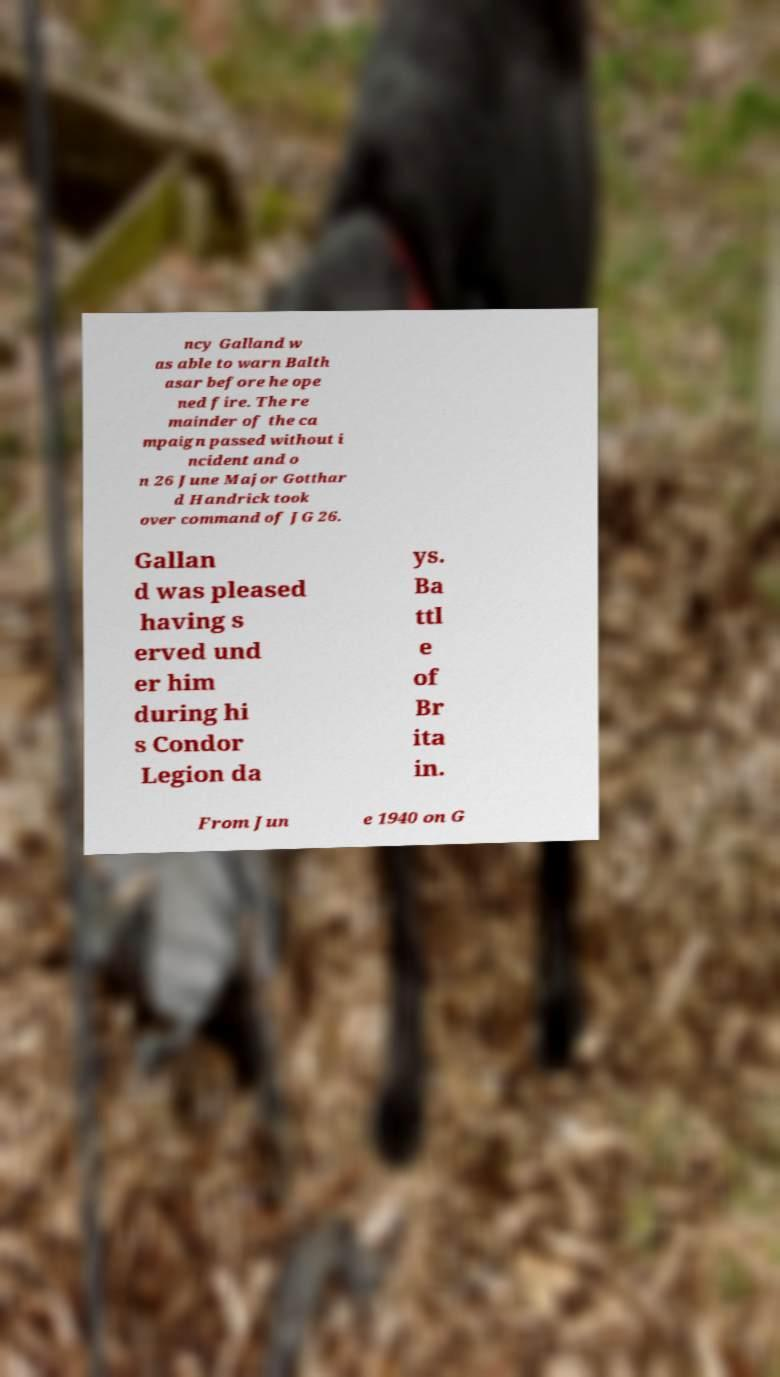For documentation purposes, I need the text within this image transcribed. Could you provide that? ncy Galland w as able to warn Balth asar before he ope ned fire. The re mainder of the ca mpaign passed without i ncident and o n 26 June Major Gotthar d Handrick took over command of JG 26. Gallan d was pleased having s erved und er him during hi s Condor Legion da ys. Ba ttl e of Br ita in. From Jun e 1940 on G 